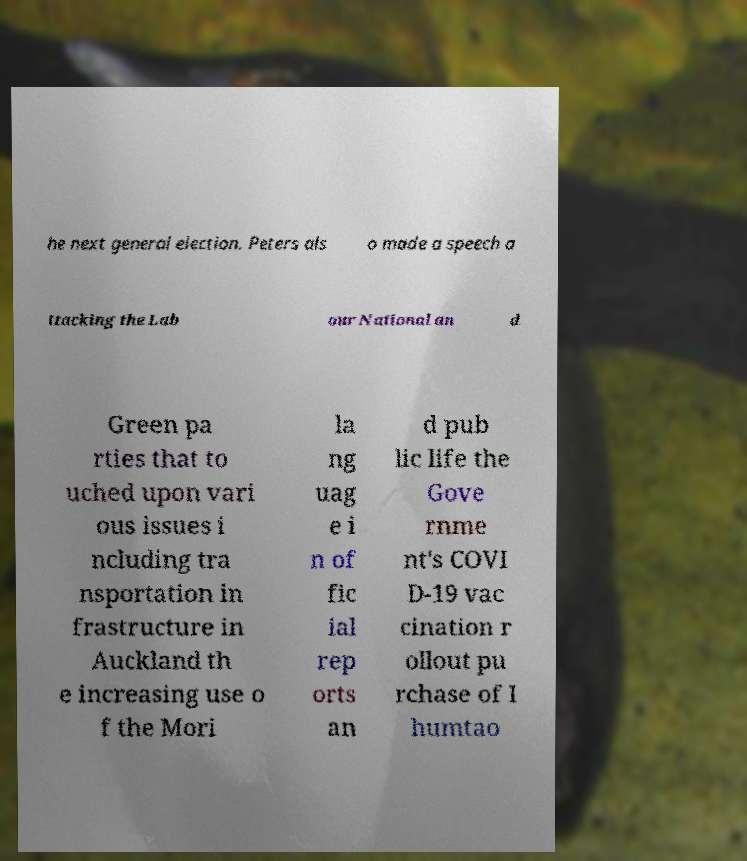I need the written content from this picture converted into text. Can you do that? he next general election. Peters als o made a speech a ttacking the Lab our National an d Green pa rties that to uched upon vari ous issues i ncluding tra nsportation in frastructure in Auckland th e increasing use o f the Mori la ng uag e i n of fic ial rep orts an d pub lic life the Gove rnme nt's COVI D-19 vac cination r ollout pu rchase of I humtao 